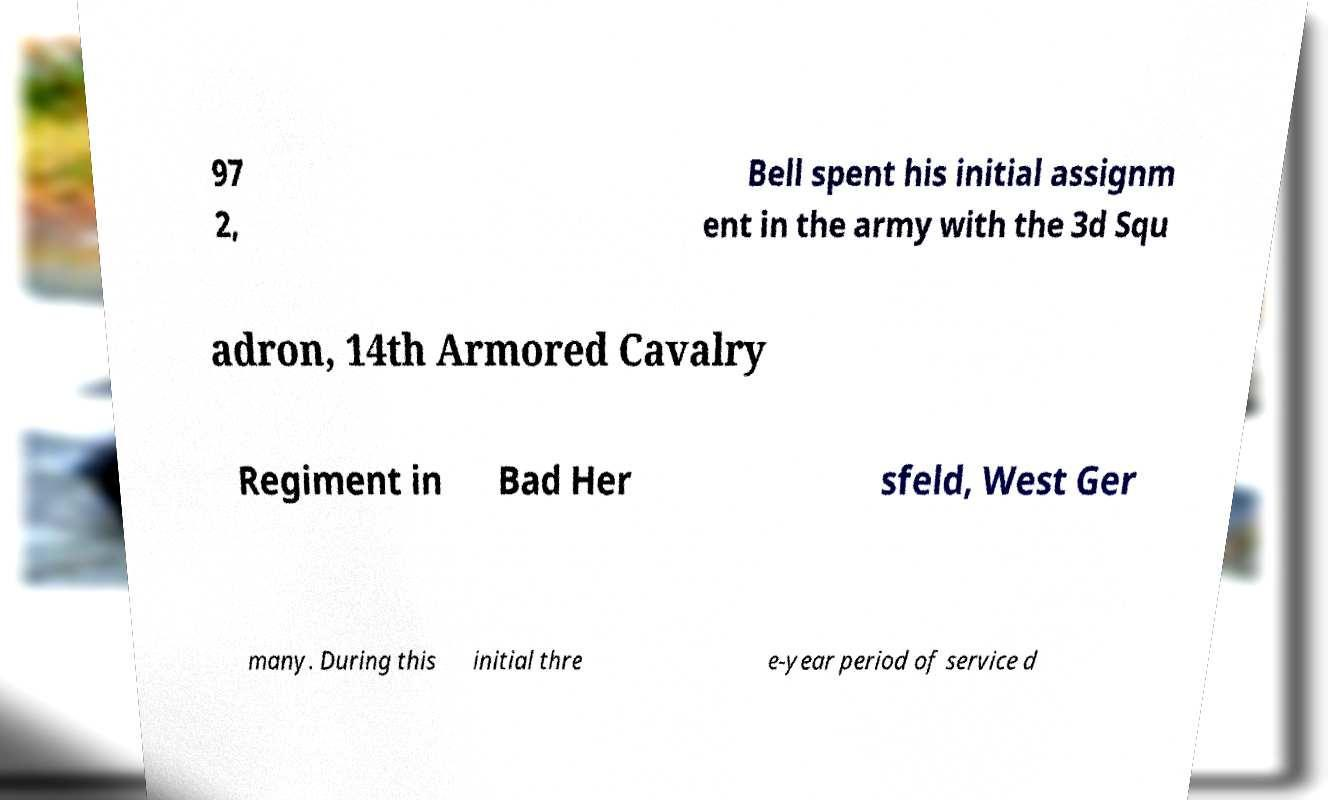Please identify and transcribe the text found in this image. 97 2, Bell spent his initial assignm ent in the army with the 3d Squ adron, 14th Armored Cavalry Regiment in Bad Her sfeld, West Ger many. During this initial thre e-year period of service d 